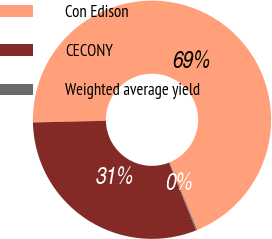Convert chart to OTSL. <chart><loc_0><loc_0><loc_500><loc_500><pie_chart><fcel>Con Edison<fcel>CECONY<fcel>Weighted average yield<nl><fcel>69.18%<fcel>30.68%<fcel>0.15%<nl></chart> 